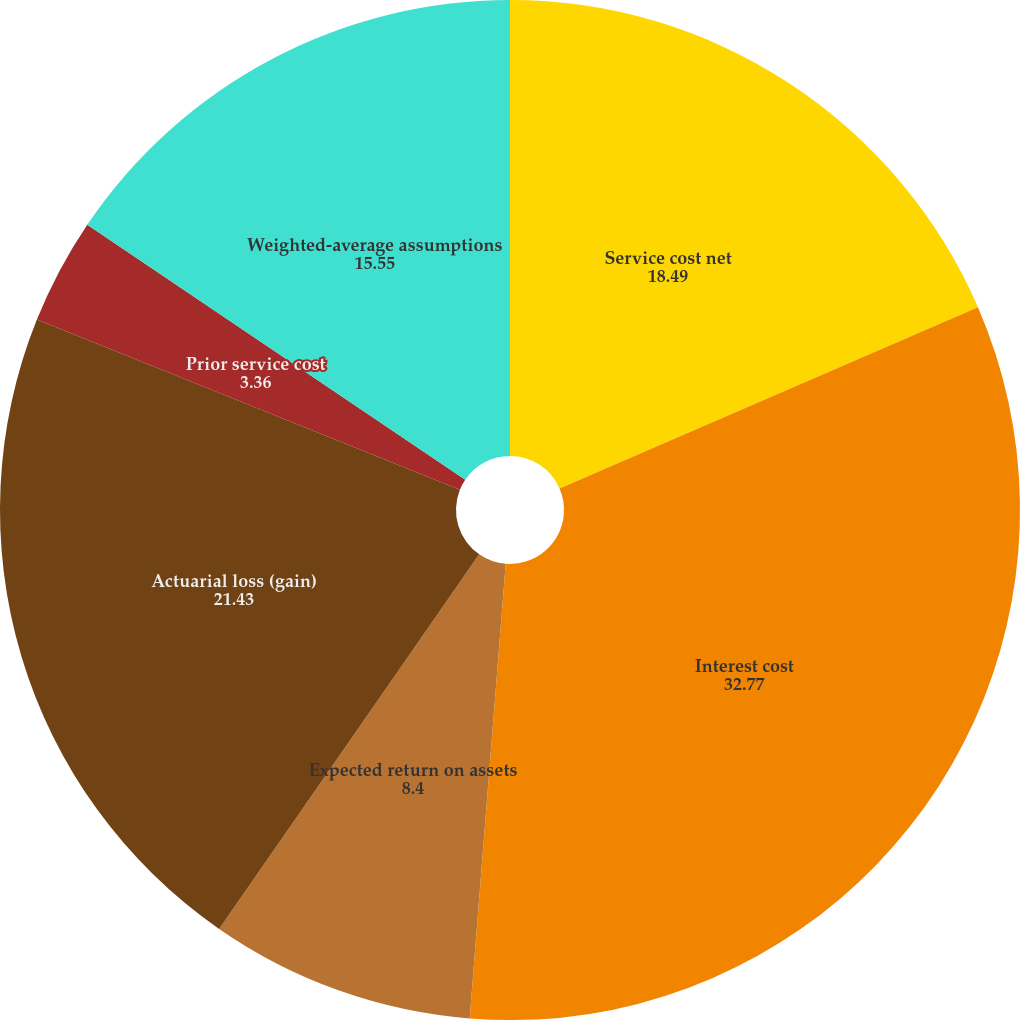<chart> <loc_0><loc_0><loc_500><loc_500><pie_chart><fcel>Service cost net<fcel>Interest cost<fcel>Expected return on assets<fcel>Actuarial loss (gain)<fcel>Prior service cost<fcel>Weighted-average assumptions<nl><fcel>18.49%<fcel>32.77%<fcel>8.4%<fcel>21.43%<fcel>3.36%<fcel>15.55%<nl></chart> 